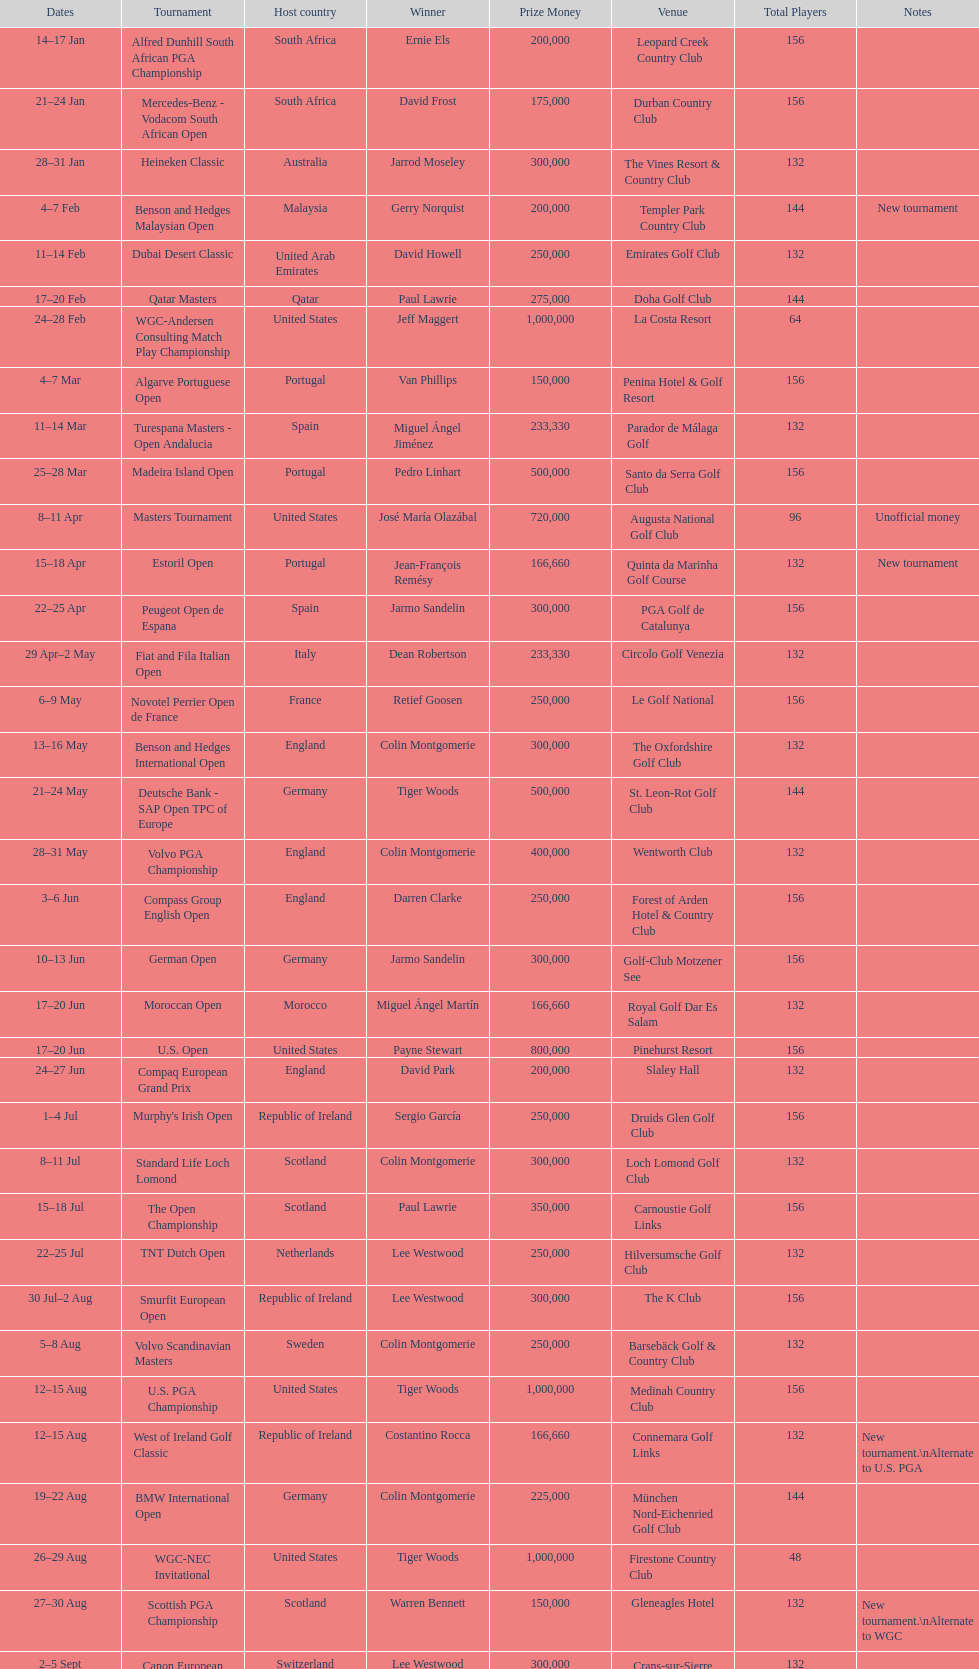What was the country listed the first time there was a new tournament? Malaysia. 